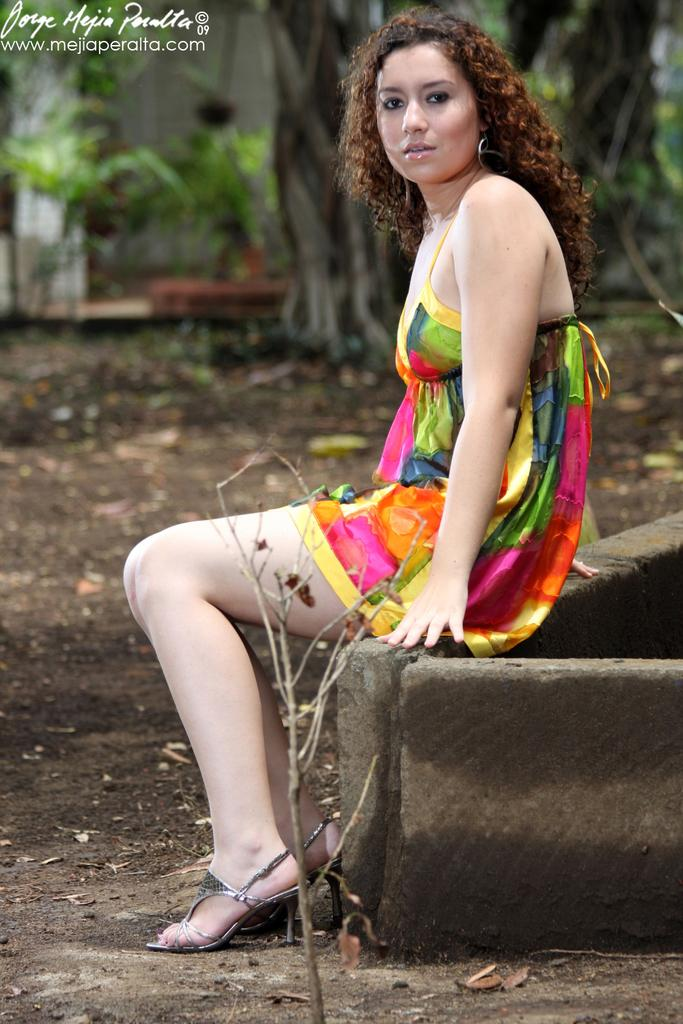What is the girl doing in the image? The girl is sitting on a platform in the image. Can you describe the platform's location? The platform is on the ground. What can be seen in the background of the image? There are trees, plants, leaves on the ground, and a wall visible in the background of the image. What type of eggnog is the girl drinking in the image? There is no eggnog present in the image; the girl is sitting on a platform. What time of day is depicted in the image? The provided facts do not give any information about the time of day, so it cannot be determined from the image. 